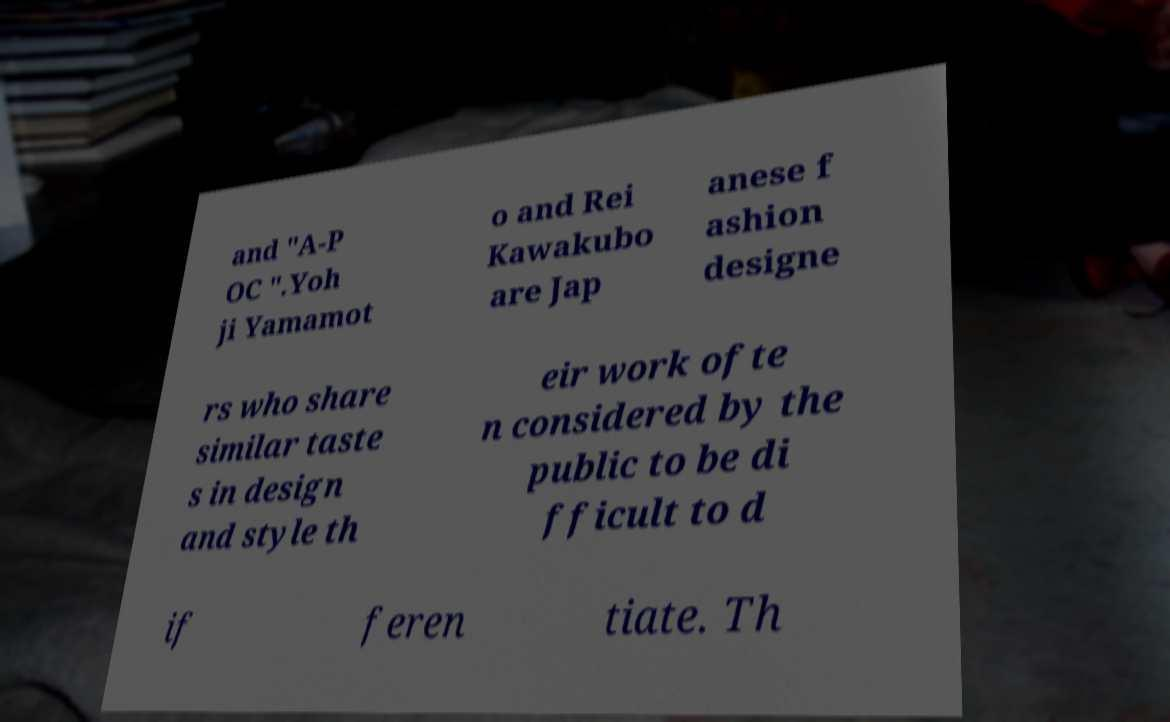Please identify and transcribe the text found in this image. and "A-P OC ".Yoh ji Yamamot o and Rei Kawakubo are Jap anese f ashion designe rs who share similar taste s in design and style th eir work ofte n considered by the public to be di fficult to d if feren tiate. Th 